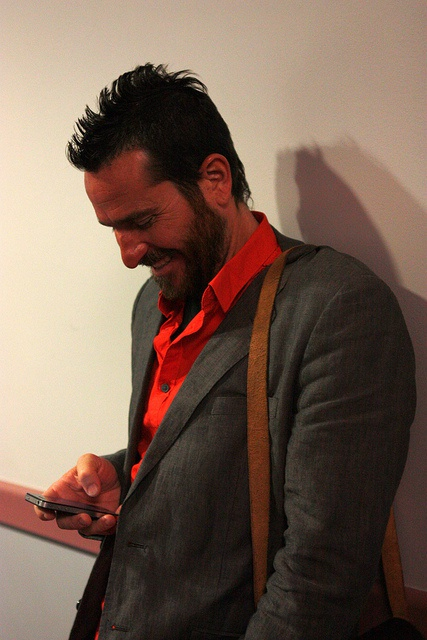Describe the objects in this image and their specific colors. I can see people in tan, black, maroon, and brown tones, handbag in tan, maroon, black, and brown tones, and cell phone in tan, black, maroon, and gray tones in this image. 